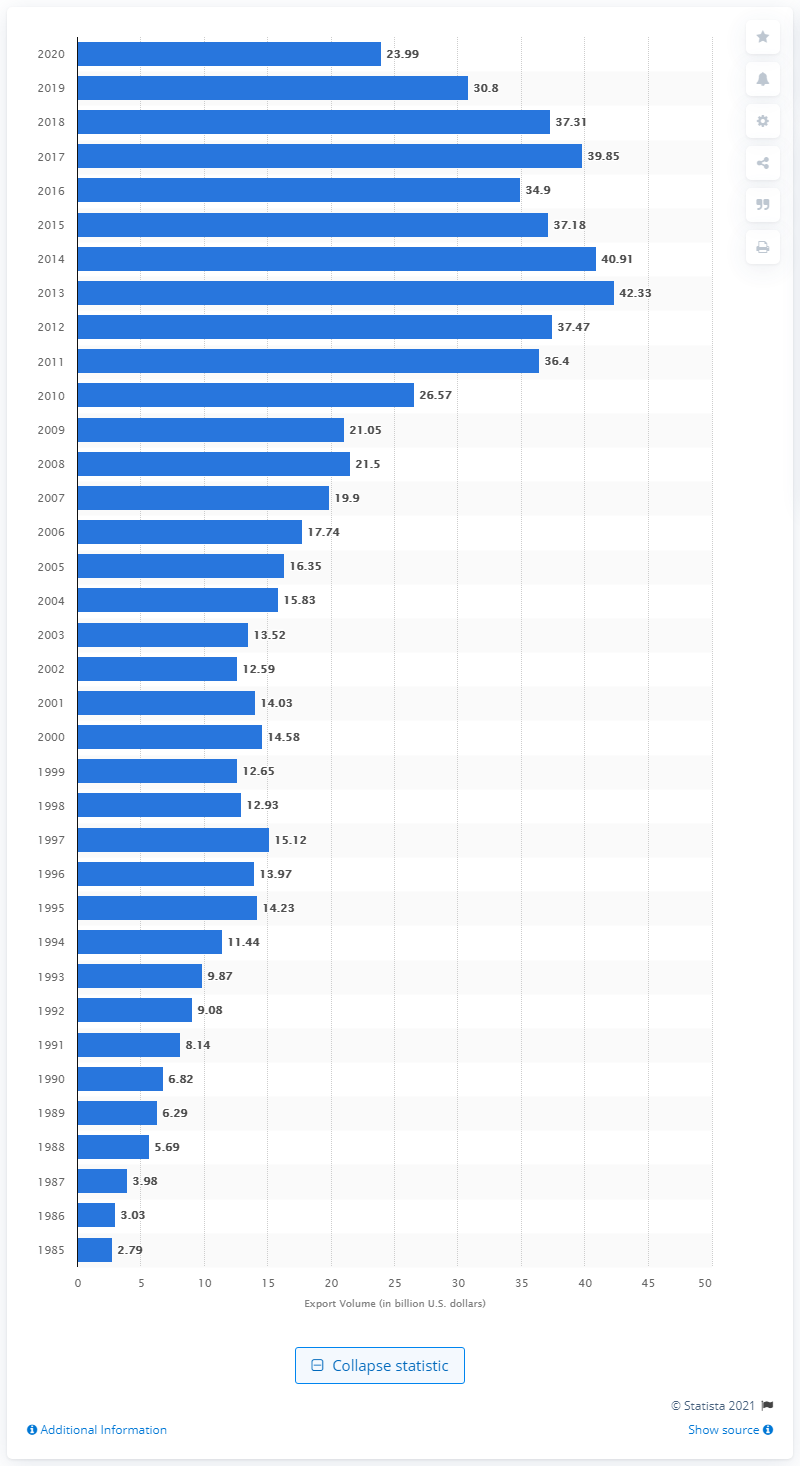Outline some significant characteristics in this image. In 2020, the United States exported 23.99 billion dollars to Hong Kong. 